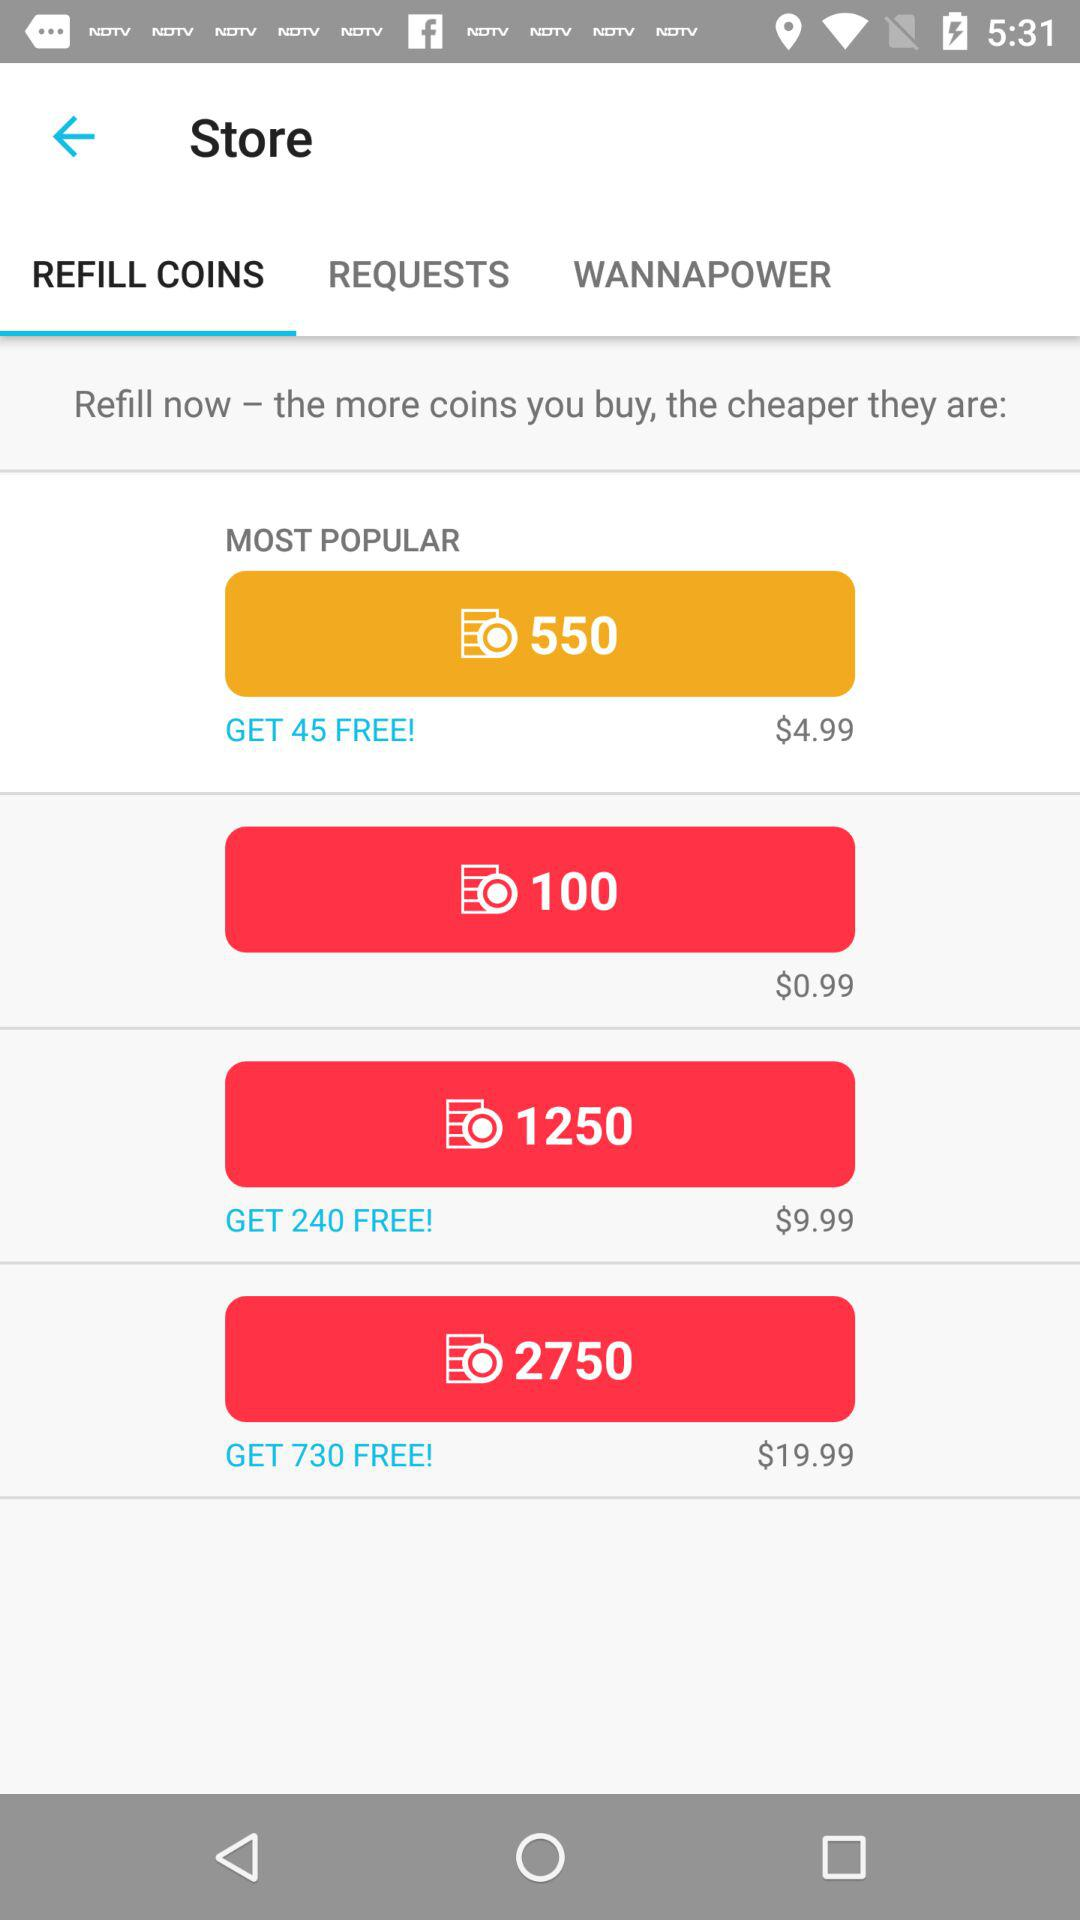What is the price of 550 coins? The price of 550 coins is $4.99. 